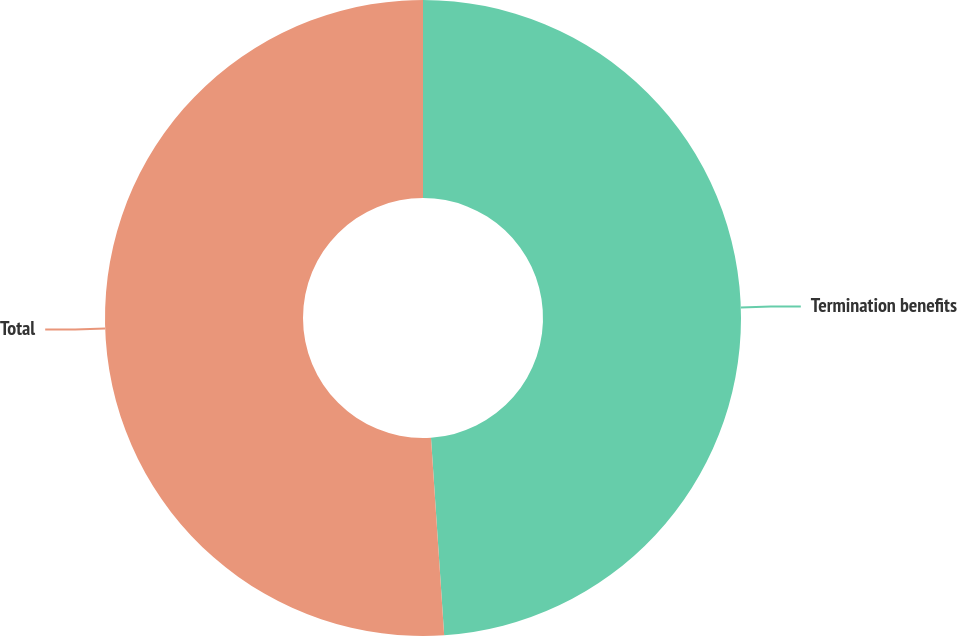Convert chart. <chart><loc_0><loc_0><loc_500><loc_500><pie_chart><fcel>Termination benefits<fcel>Total<nl><fcel>48.94%<fcel>51.06%<nl></chart> 